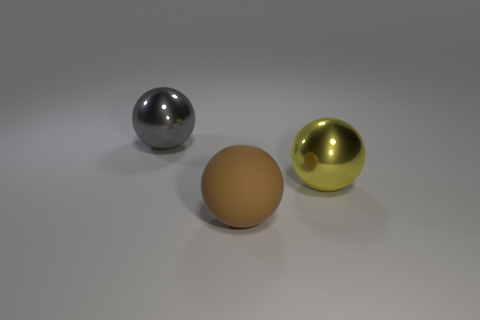What number of blocks are big objects or large green objects?
Offer a very short reply. 0. There is a ball that is behind the metallic sphere right of the matte ball; how many big metal objects are on the left side of it?
Keep it short and to the point. 0. There is a large gray object that is the same shape as the brown object; what is its material?
Offer a terse response. Metal. Is there anything else that is the same material as the brown thing?
Provide a succinct answer. No. There is a big object left of the big brown ball; what color is it?
Offer a very short reply. Gray. Does the yellow thing have the same material as the big object that is in front of the big yellow metal thing?
Keep it short and to the point. No. What is the yellow object made of?
Offer a very short reply. Metal. What shape is the large thing that is the same material as the big gray ball?
Your answer should be compact. Sphere. What number of other objects are the same shape as the big brown matte thing?
Your answer should be very brief. 2. How many big brown objects are to the left of the brown ball?
Provide a succinct answer. 0. 